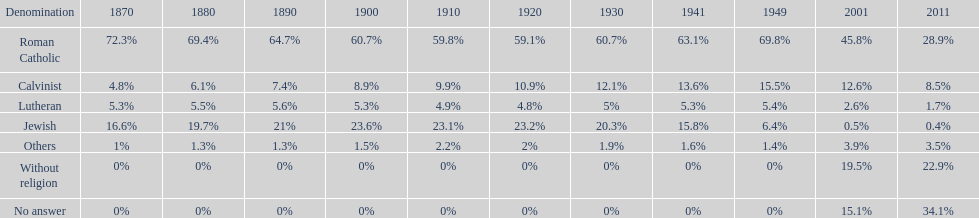How many denominations never dropped below 20%? 1. 